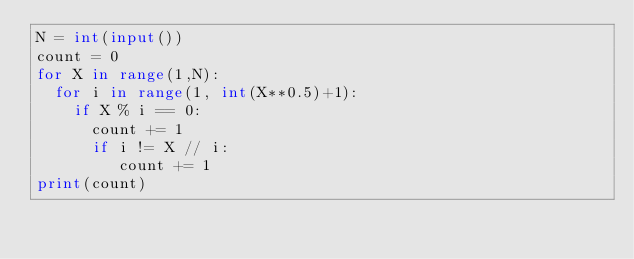<code> <loc_0><loc_0><loc_500><loc_500><_Python_>N = int(input())
count = 0
for X in range(1,N):
  for i in range(1, int(X**0.5)+1):
    if X % i == 0:
      count += 1
      if i != X // i:
         count += 1
print(count)
  </code> 